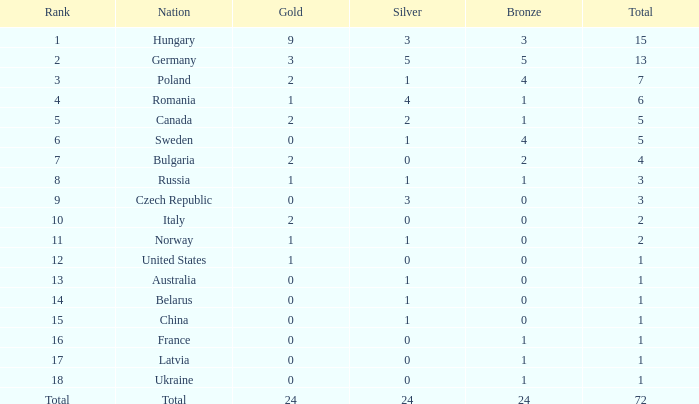Which country has 0 for silver, 1 for bronze, and a ranking of 18? Ukraine. 